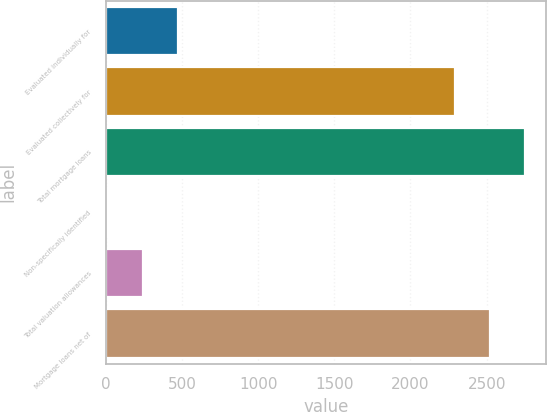Convert chart to OTSL. <chart><loc_0><loc_0><loc_500><loc_500><bar_chart><fcel>Evaluated individually for<fcel>Evaluated collectively for<fcel>Total mortgage loans<fcel>Non-specifically identified<fcel>Total valuation allowances<fcel>Mortgage loans net of<nl><fcel>472.8<fcel>2293<fcel>2751.8<fcel>14<fcel>243.4<fcel>2522.4<nl></chart> 